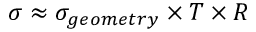Convert formula to latex. <formula><loc_0><loc_0><loc_500><loc_500>\sigma \approx \sigma _ { g e o m e t r y } \times T \times R</formula> 